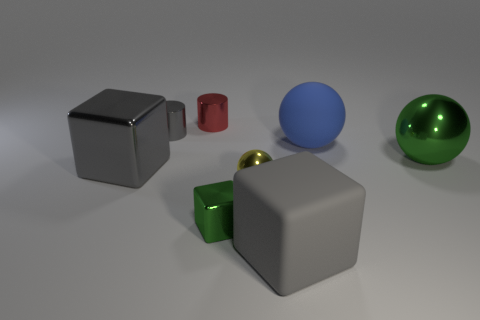What is the material of the small object that is the same color as the large metal ball?
Provide a succinct answer. Metal. How many balls are yellow metal objects or small metal things?
Ensure brevity in your answer.  1. What number of gray things are both right of the big metallic cube and left of the gray matte thing?
Ensure brevity in your answer.  1. There is a green metal block; is it the same size as the ball that is to the right of the matte ball?
Your answer should be compact. No. Is there a yellow metallic object that is in front of the green object on the left side of the big sphere that is in front of the big blue rubber thing?
Your answer should be compact. No. There is a large gray thing that is in front of the gray metal thing in front of the large green metallic sphere; what is its material?
Give a very brief answer. Rubber. What is the gray thing that is both behind the small block and to the right of the large metal cube made of?
Your answer should be compact. Metal. Is there a small gray thing that has the same shape as the big green metallic thing?
Your answer should be compact. No. There is a gray cube that is to the left of the small gray object; are there any yellow things to the left of it?
Your answer should be very brief. No. How many other small things have the same material as the tiny green object?
Your answer should be very brief. 3. 